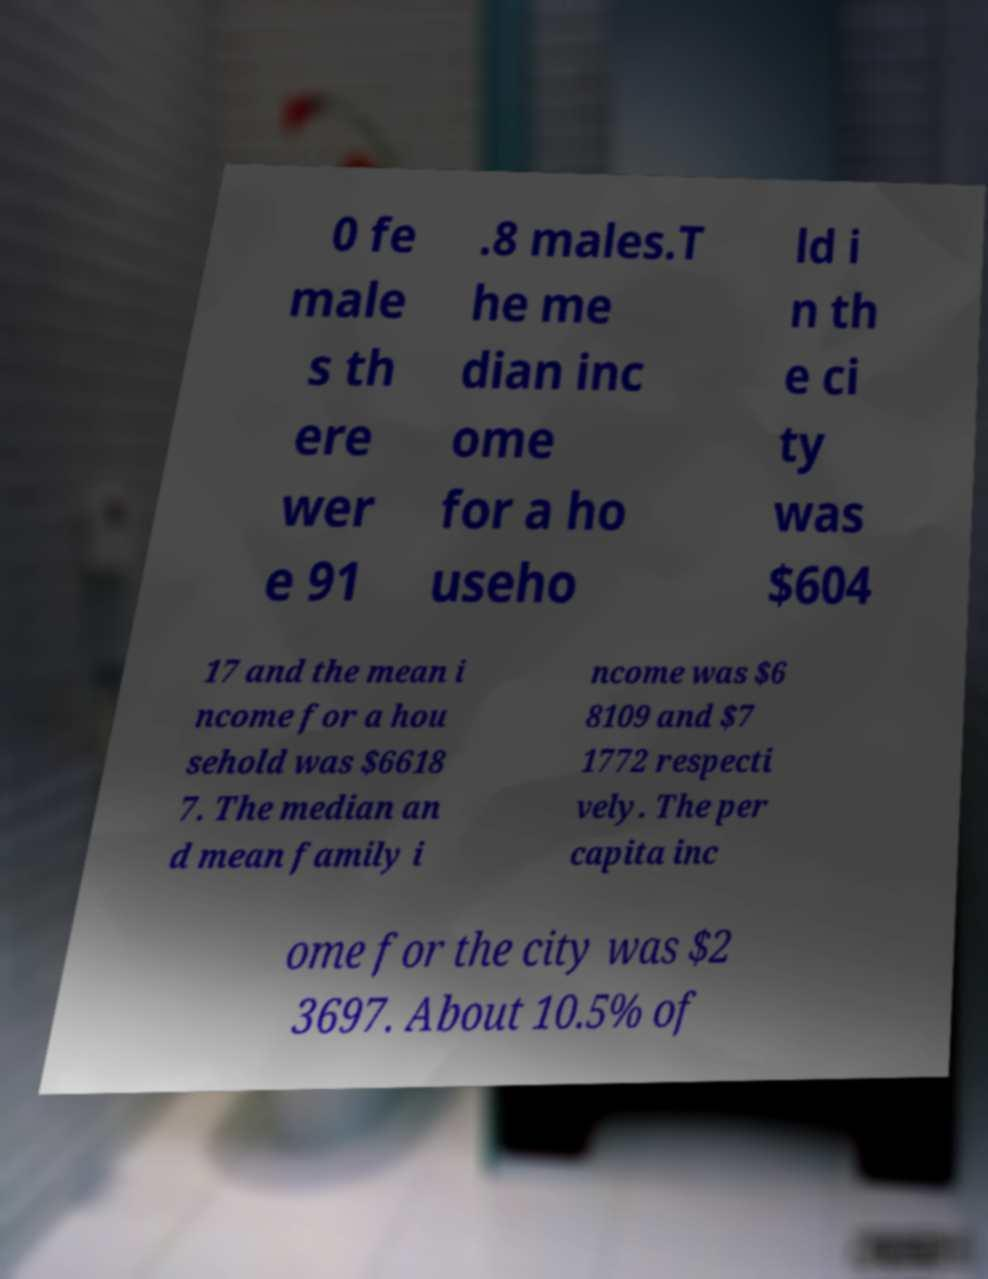What messages or text are displayed in this image? I need them in a readable, typed format. 0 fe male s th ere wer e 91 .8 males.T he me dian inc ome for a ho useho ld i n th e ci ty was $604 17 and the mean i ncome for a hou sehold was $6618 7. The median an d mean family i ncome was $6 8109 and $7 1772 respecti vely. The per capita inc ome for the city was $2 3697. About 10.5% of 